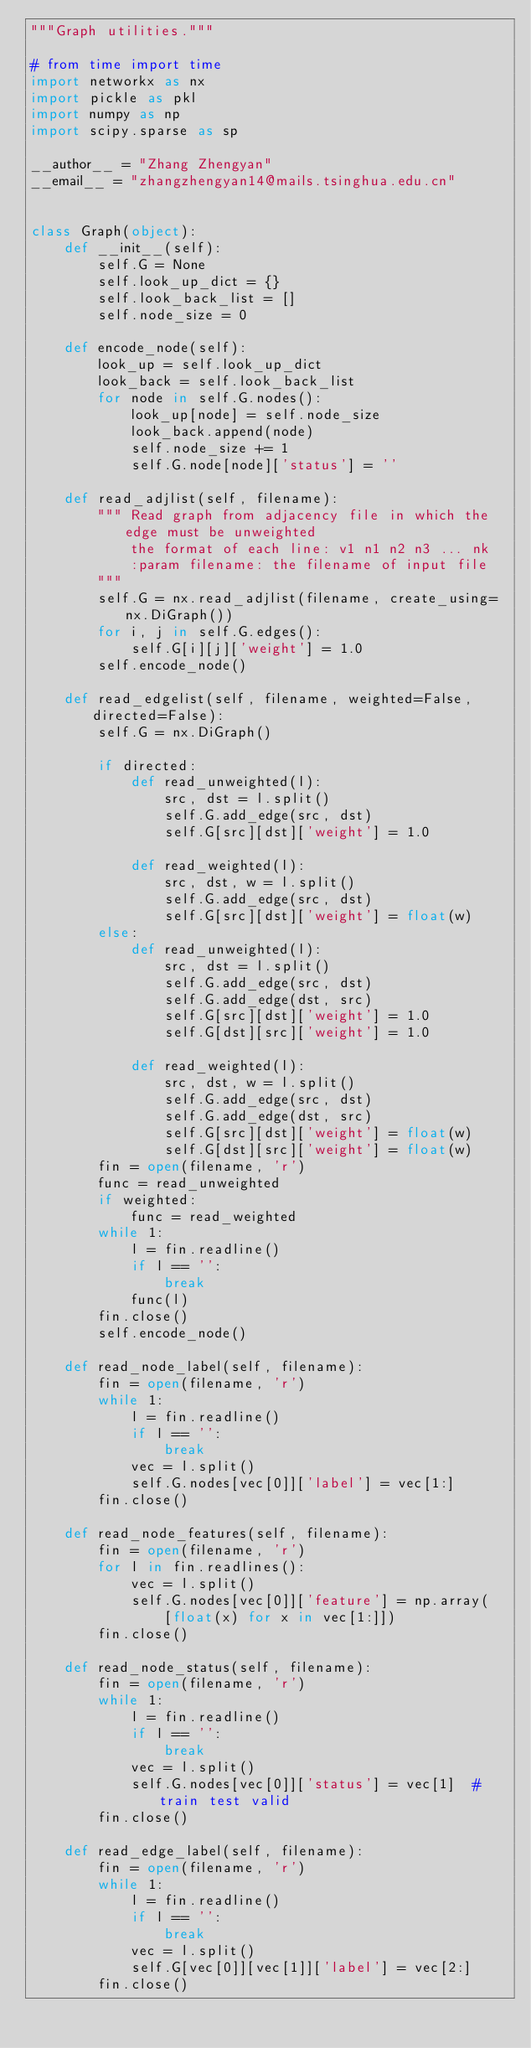Convert code to text. <code><loc_0><loc_0><loc_500><loc_500><_Python_>"""Graph utilities."""

# from time import time
import networkx as nx
import pickle as pkl
import numpy as np
import scipy.sparse as sp

__author__ = "Zhang Zhengyan"
__email__ = "zhangzhengyan14@mails.tsinghua.edu.cn"


class Graph(object):
    def __init__(self):
        self.G = None
        self.look_up_dict = {}
        self.look_back_list = []
        self.node_size = 0

    def encode_node(self):
        look_up = self.look_up_dict
        look_back = self.look_back_list
        for node in self.G.nodes():
            look_up[node] = self.node_size
            look_back.append(node)
            self.node_size += 1
            self.G.node[node]['status'] = ''

    def read_adjlist(self, filename):
        """ Read graph from adjacency file in which the edge must be unweighted
            the format of each line: v1 n1 n2 n3 ... nk
            :param filename: the filename of input file
        """
        self.G = nx.read_adjlist(filename, create_using=nx.DiGraph())
        for i, j in self.G.edges():
            self.G[i][j]['weight'] = 1.0
        self.encode_node()

    def read_edgelist(self, filename, weighted=False, directed=False):
        self.G = nx.DiGraph()

        if directed:
            def read_unweighted(l):
                src, dst = l.split()
                self.G.add_edge(src, dst)
                self.G[src][dst]['weight'] = 1.0

            def read_weighted(l):
                src, dst, w = l.split()
                self.G.add_edge(src, dst)
                self.G[src][dst]['weight'] = float(w)
        else:
            def read_unweighted(l):
                src, dst = l.split()
                self.G.add_edge(src, dst)
                self.G.add_edge(dst, src)
                self.G[src][dst]['weight'] = 1.0
                self.G[dst][src]['weight'] = 1.0

            def read_weighted(l):
                src, dst, w = l.split()
                self.G.add_edge(src, dst)
                self.G.add_edge(dst, src)
                self.G[src][dst]['weight'] = float(w)
                self.G[dst][src]['weight'] = float(w)
        fin = open(filename, 'r')
        func = read_unweighted
        if weighted:
            func = read_weighted
        while 1:
            l = fin.readline()
            if l == '':
                break
            func(l)
        fin.close()
        self.encode_node()

    def read_node_label(self, filename):
        fin = open(filename, 'r')
        while 1:
            l = fin.readline()
            if l == '':
                break
            vec = l.split()
            self.G.nodes[vec[0]]['label'] = vec[1:]
        fin.close()

    def read_node_features(self, filename):
        fin = open(filename, 'r')
        for l in fin.readlines():
            vec = l.split()
            self.G.nodes[vec[0]]['feature'] = np.array(
                [float(x) for x in vec[1:]])
        fin.close()

    def read_node_status(self, filename):
        fin = open(filename, 'r')
        while 1:
            l = fin.readline()
            if l == '':
                break
            vec = l.split()
            self.G.nodes[vec[0]]['status'] = vec[1]  # train test valid
        fin.close()

    def read_edge_label(self, filename):
        fin = open(filename, 'r')
        while 1:
            l = fin.readline()
            if l == '':
                break
            vec = l.split()
            self.G[vec[0]][vec[1]]['label'] = vec[2:]
        fin.close()
</code> 